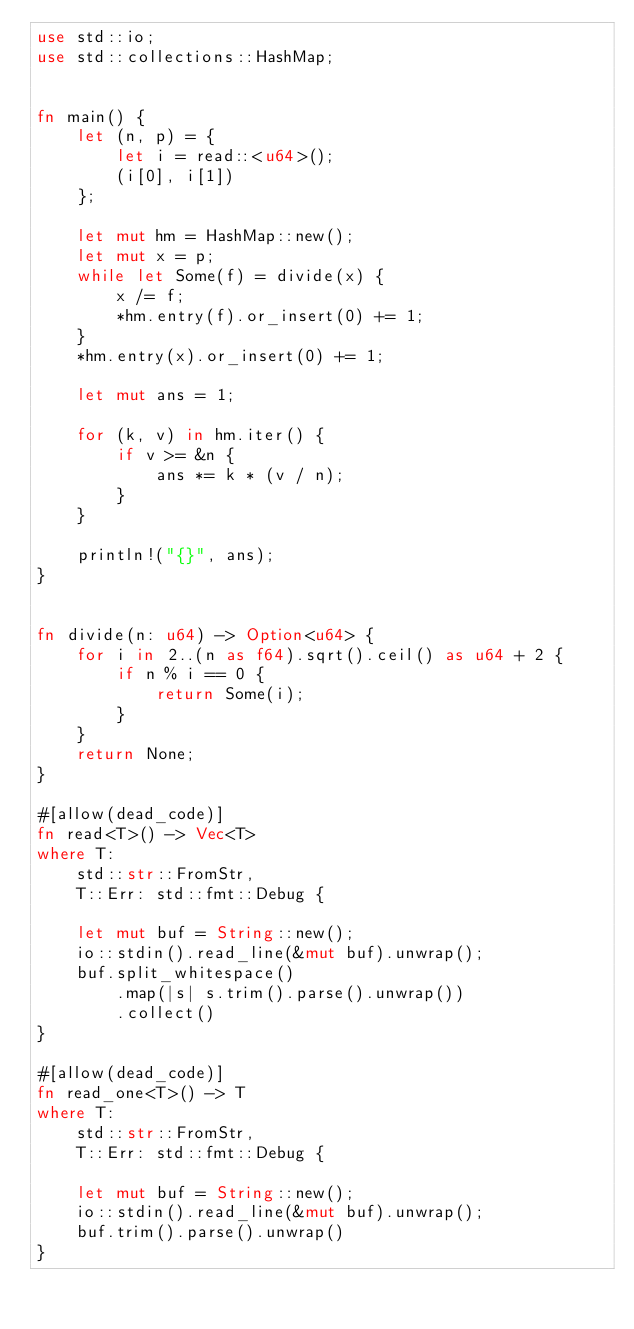Convert code to text. <code><loc_0><loc_0><loc_500><loc_500><_Rust_>use std::io;
use std::collections::HashMap;


fn main() {
    let (n, p) = {
        let i = read::<u64>();
        (i[0], i[1])
    };

    let mut hm = HashMap::new();
    let mut x = p;
    while let Some(f) = divide(x) {
        x /= f;
        *hm.entry(f).or_insert(0) += 1;
    }
    *hm.entry(x).or_insert(0) += 1;

    let mut ans = 1;

    for (k, v) in hm.iter() {
        if v >= &n {
            ans *= k * (v / n);
        }
    }

    println!("{}", ans);
}


fn divide(n: u64) -> Option<u64> {
    for i in 2..(n as f64).sqrt().ceil() as u64 + 2 {
        if n % i == 0 {
            return Some(i);
        }
    } 
    return None;
}

#[allow(dead_code)]
fn read<T>() -> Vec<T>
where T:
    std::str::FromStr,
    T::Err: std::fmt::Debug {

    let mut buf = String::new();
    io::stdin().read_line(&mut buf).unwrap();
    buf.split_whitespace()
        .map(|s| s.trim().parse().unwrap())
        .collect()
}

#[allow(dead_code)]
fn read_one<T>() -> T
where T:
    std::str::FromStr,
    T::Err: std::fmt::Debug {

    let mut buf = String::new();
    io::stdin().read_line(&mut buf).unwrap();
    buf.trim().parse().unwrap()
}</code> 